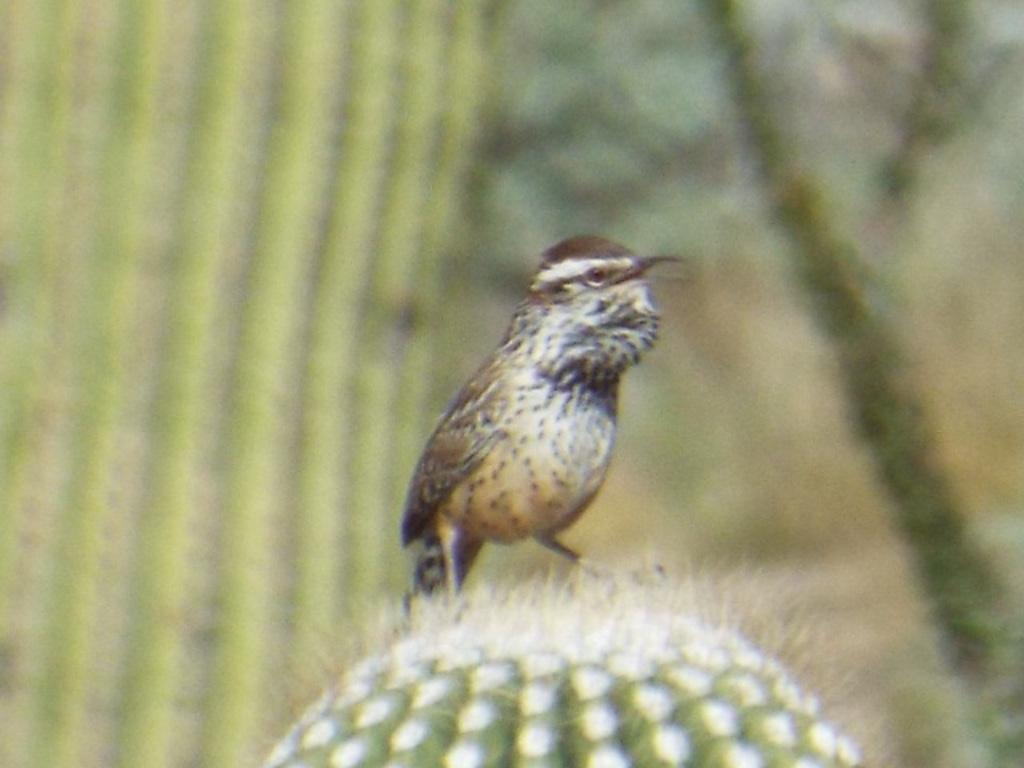Can you describe this image briefly? In this picture there is a bird in the center of the image and the background area of the image is blur. 